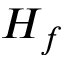Convert formula to latex. <formula><loc_0><loc_0><loc_500><loc_500>H _ { f }</formula> 